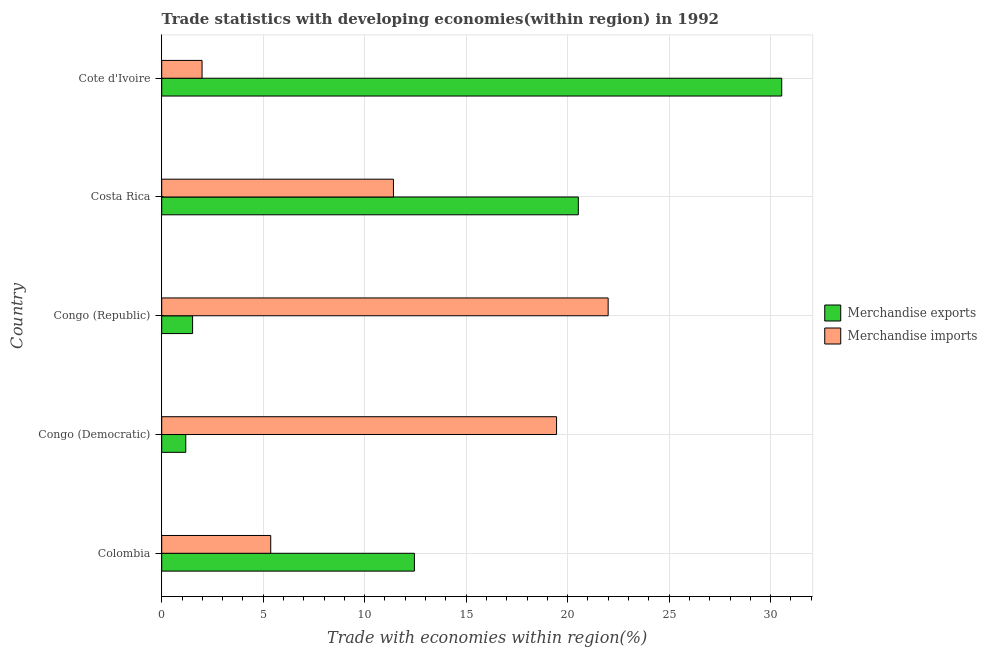How many different coloured bars are there?
Give a very brief answer. 2. Are the number of bars per tick equal to the number of legend labels?
Ensure brevity in your answer.  Yes. How many bars are there on the 1st tick from the bottom?
Make the answer very short. 2. What is the label of the 3rd group of bars from the top?
Give a very brief answer. Congo (Republic). In how many cases, is the number of bars for a given country not equal to the number of legend labels?
Provide a short and direct response. 0. What is the merchandise imports in Colombia?
Make the answer very short. 5.37. Across all countries, what is the maximum merchandise exports?
Keep it short and to the point. 30.55. Across all countries, what is the minimum merchandise exports?
Provide a short and direct response. 1.19. In which country was the merchandise imports maximum?
Offer a terse response. Congo (Republic). In which country was the merchandise imports minimum?
Keep it short and to the point. Cote d'Ivoire. What is the total merchandise imports in the graph?
Your answer should be compact. 60.22. What is the difference between the merchandise exports in Congo (Democratic) and that in Congo (Republic)?
Your answer should be compact. -0.34. What is the difference between the merchandise exports in Costa Rica and the merchandise imports in Congo (Republic)?
Make the answer very short. -1.47. What is the average merchandise imports per country?
Offer a very short reply. 12.04. What is the difference between the merchandise exports and merchandise imports in Colombia?
Make the answer very short. 7.08. What is the ratio of the merchandise exports in Congo (Democratic) to that in Costa Rica?
Your answer should be very brief. 0.06. What is the difference between the highest and the second highest merchandise exports?
Offer a very short reply. 10.02. What is the difference between the highest and the lowest merchandise exports?
Give a very brief answer. 29.36. In how many countries, is the merchandise imports greater than the average merchandise imports taken over all countries?
Keep it short and to the point. 2. What does the 2nd bar from the top in Colombia represents?
Ensure brevity in your answer.  Merchandise exports. Are all the bars in the graph horizontal?
Give a very brief answer. Yes. How many countries are there in the graph?
Offer a very short reply. 5. What is the difference between two consecutive major ticks on the X-axis?
Make the answer very short. 5. Where does the legend appear in the graph?
Keep it short and to the point. Center right. What is the title of the graph?
Provide a short and direct response. Trade statistics with developing economies(within region) in 1992. What is the label or title of the X-axis?
Your answer should be compact. Trade with economies within region(%). What is the Trade with economies within region(%) of Merchandise exports in Colombia?
Give a very brief answer. 12.45. What is the Trade with economies within region(%) in Merchandise imports in Colombia?
Keep it short and to the point. 5.37. What is the Trade with economies within region(%) of Merchandise exports in Congo (Democratic)?
Make the answer very short. 1.19. What is the Trade with economies within region(%) in Merchandise imports in Congo (Democratic)?
Keep it short and to the point. 19.45. What is the Trade with economies within region(%) in Merchandise exports in Congo (Republic)?
Keep it short and to the point. 1.52. What is the Trade with economies within region(%) of Merchandise imports in Congo (Republic)?
Make the answer very short. 22. What is the Trade with economies within region(%) in Merchandise exports in Costa Rica?
Give a very brief answer. 20.53. What is the Trade with economies within region(%) of Merchandise imports in Costa Rica?
Make the answer very short. 11.42. What is the Trade with economies within region(%) of Merchandise exports in Cote d'Ivoire?
Provide a succinct answer. 30.55. What is the Trade with economies within region(%) in Merchandise imports in Cote d'Ivoire?
Make the answer very short. 1.99. Across all countries, what is the maximum Trade with economies within region(%) in Merchandise exports?
Provide a short and direct response. 30.55. Across all countries, what is the maximum Trade with economies within region(%) of Merchandise imports?
Your answer should be compact. 22. Across all countries, what is the minimum Trade with economies within region(%) of Merchandise exports?
Your answer should be very brief. 1.19. Across all countries, what is the minimum Trade with economies within region(%) in Merchandise imports?
Ensure brevity in your answer.  1.99. What is the total Trade with economies within region(%) in Merchandise exports in the graph?
Ensure brevity in your answer.  66.23. What is the total Trade with economies within region(%) of Merchandise imports in the graph?
Offer a very short reply. 60.22. What is the difference between the Trade with economies within region(%) in Merchandise exports in Colombia and that in Congo (Democratic)?
Provide a succinct answer. 11.26. What is the difference between the Trade with economies within region(%) in Merchandise imports in Colombia and that in Congo (Democratic)?
Your answer should be compact. -14.08. What is the difference between the Trade with economies within region(%) of Merchandise exports in Colombia and that in Congo (Republic)?
Provide a succinct answer. 10.93. What is the difference between the Trade with economies within region(%) in Merchandise imports in Colombia and that in Congo (Republic)?
Ensure brevity in your answer.  -16.62. What is the difference between the Trade with economies within region(%) in Merchandise exports in Colombia and that in Costa Rica?
Provide a short and direct response. -8.08. What is the difference between the Trade with economies within region(%) of Merchandise imports in Colombia and that in Costa Rica?
Ensure brevity in your answer.  -6.05. What is the difference between the Trade with economies within region(%) of Merchandise exports in Colombia and that in Cote d'Ivoire?
Your answer should be very brief. -18.1. What is the difference between the Trade with economies within region(%) of Merchandise imports in Colombia and that in Cote d'Ivoire?
Provide a succinct answer. 3.38. What is the difference between the Trade with economies within region(%) of Merchandise exports in Congo (Democratic) and that in Congo (Republic)?
Offer a very short reply. -0.34. What is the difference between the Trade with economies within region(%) in Merchandise imports in Congo (Democratic) and that in Congo (Republic)?
Provide a short and direct response. -2.54. What is the difference between the Trade with economies within region(%) in Merchandise exports in Congo (Democratic) and that in Costa Rica?
Give a very brief answer. -19.34. What is the difference between the Trade with economies within region(%) in Merchandise imports in Congo (Democratic) and that in Costa Rica?
Give a very brief answer. 8.04. What is the difference between the Trade with economies within region(%) of Merchandise exports in Congo (Democratic) and that in Cote d'Ivoire?
Provide a succinct answer. -29.36. What is the difference between the Trade with economies within region(%) in Merchandise imports in Congo (Democratic) and that in Cote d'Ivoire?
Keep it short and to the point. 17.46. What is the difference between the Trade with economies within region(%) in Merchandise exports in Congo (Republic) and that in Costa Rica?
Give a very brief answer. -19. What is the difference between the Trade with economies within region(%) of Merchandise imports in Congo (Republic) and that in Costa Rica?
Your answer should be compact. 10.58. What is the difference between the Trade with economies within region(%) of Merchandise exports in Congo (Republic) and that in Cote d'Ivoire?
Give a very brief answer. -29.02. What is the difference between the Trade with economies within region(%) of Merchandise imports in Congo (Republic) and that in Cote d'Ivoire?
Give a very brief answer. 20.01. What is the difference between the Trade with economies within region(%) in Merchandise exports in Costa Rica and that in Cote d'Ivoire?
Keep it short and to the point. -10.02. What is the difference between the Trade with economies within region(%) of Merchandise imports in Costa Rica and that in Cote d'Ivoire?
Your answer should be compact. 9.43. What is the difference between the Trade with economies within region(%) in Merchandise exports in Colombia and the Trade with economies within region(%) in Merchandise imports in Congo (Democratic)?
Give a very brief answer. -7. What is the difference between the Trade with economies within region(%) in Merchandise exports in Colombia and the Trade with economies within region(%) in Merchandise imports in Congo (Republic)?
Keep it short and to the point. -9.55. What is the difference between the Trade with economies within region(%) in Merchandise exports in Colombia and the Trade with economies within region(%) in Merchandise imports in Costa Rica?
Ensure brevity in your answer.  1.03. What is the difference between the Trade with economies within region(%) of Merchandise exports in Colombia and the Trade with economies within region(%) of Merchandise imports in Cote d'Ivoire?
Provide a succinct answer. 10.46. What is the difference between the Trade with economies within region(%) of Merchandise exports in Congo (Democratic) and the Trade with economies within region(%) of Merchandise imports in Congo (Republic)?
Provide a short and direct response. -20.81. What is the difference between the Trade with economies within region(%) of Merchandise exports in Congo (Democratic) and the Trade with economies within region(%) of Merchandise imports in Costa Rica?
Your response must be concise. -10.23. What is the difference between the Trade with economies within region(%) of Merchandise exports in Congo (Democratic) and the Trade with economies within region(%) of Merchandise imports in Cote d'Ivoire?
Your answer should be compact. -0.8. What is the difference between the Trade with economies within region(%) in Merchandise exports in Congo (Republic) and the Trade with economies within region(%) in Merchandise imports in Costa Rica?
Offer a terse response. -9.9. What is the difference between the Trade with economies within region(%) in Merchandise exports in Congo (Republic) and the Trade with economies within region(%) in Merchandise imports in Cote d'Ivoire?
Offer a very short reply. -0.47. What is the difference between the Trade with economies within region(%) of Merchandise exports in Costa Rica and the Trade with economies within region(%) of Merchandise imports in Cote d'Ivoire?
Ensure brevity in your answer.  18.54. What is the average Trade with economies within region(%) in Merchandise exports per country?
Keep it short and to the point. 13.25. What is the average Trade with economies within region(%) in Merchandise imports per country?
Provide a short and direct response. 12.04. What is the difference between the Trade with economies within region(%) of Merchandise exports and Trade with economies within region(%) of Merchandise imports in Colombia?
Keep it short and to the point. 7.08. What is the difference between the Trade with economies within region(%) of Merchandise exports and Trade with economies within region(%) of Merchandise imports in Congo (Democratic)?
Offer a very short reply. -18.27. What is the difference between the Trade with economies within region(%) in Merchandise exports and Trade with economies within region(%) in Merchandise imports in Congo (Republic)?
Give a very brief answer. -20.47. What is the difference between the Trade with economies within region(%) of Merchandise exports and Trade with economies within region(%) of Merchandise imports in Costa Rica?
Give a very brief answer. 9.11. What is the difference between the Trade with economies within region(%) of Merchandise exports and Trade with economies within region(%) of Merchandise imports in Cote d'Ivoire?
Offer a very short reply. 28.56. What is the ratio of the Trade with economies within region(%) in Merchandise exports in Colombia to that in Congo (Democratic)?
Offer a terse response. 10.51. What is the ratio of the Trade with economies within region(%) of Merchandise imports in Colombia to that in Congo (Democratic)?
Provide a succinct answer. 0.28. What is the ratio of the Trade with economies within region(%) of Merchandise exports in Colombia to that in Congo (Republic)?
Make the answer very short. 8.18. What is the ratio of the Trade with economies within region(%) of Merchandise imports in Colombia to that in Congo (Republic)?
Give a very brief answer. 0.24. What is the ratio of the Trade with economies within region(%) in Merchandise exports in Colombia to that in Costa Rica?
Your response must be concise. 0.61. What is the ratio of the Trade with economies within region(%) of Merchandise imports in Colombia to that in Costa Rica?
Your response must be concise. 0.47. What is the ratio of the Trade with economies within region(%) of Merchandise exports in Colombia to that in Cote d'Ivoire?
Make the answer very short. 0.41. What is the ratio of the Trade with economies within region(%) in Merchandise imports in Colombia to that in Cote d'Ivoire?
Offer a terse response. 2.7. What is the ratio of the Trade with economies within region(%) of Merchandise exports in Congo (Democratic) to that in Congo (Republic)?
Provide a succinct answer. 0.78. What is the ratio of the Trade with economies within region(%) of Merchandise imports in Congo (Democratic) to that in Congo (Republic)?
Offer a terse response. 0.88. What is the ratio of the Trade with economies within region(%) of Merchandise exports in Congo (Democratic) to that in Costa Rica?
Your response must be concise. 0.06. What is the ratio of the Trade with economies within region(%) of Merchandise imports in Congo (Democratic) to that in Costa Rica?
Provide a short and direct response. 1.7. What is the ratio of the Trade with economies within region(%) of Merchandise exports in Congo (Democratic) to that in Cote d'Ivoire?
Offer a very short reply. 0.04. What is the ratio of the Trade with economies within region(%) of Merchandise imports in Congo (Democratic) to that in Cote d'Ivoire?
Provide a short and direct response. 9.78. What is the ratio of the Trade with economies within region(%) of Merchandise exports in Congo (Republic) to that in Costa Rica?
Keep it short and to the point. 0.07. What is the ratio of the Trade with economies within region(%) of Merchandise imports in Congo (Republic) to that in Costa Rica?
Keep it short and to the point. 1.93. What is the ratio of the Trade with economies within region(%) in Merchandise exports in Congo (Republic) to that in Cote d'Ivoire?
Ensure brevity in your answer.  0.05. What is the ratio of the Trade with economies within region(%) in Merchandise imports in Congo (Republic) to that in Cote d'Ivoire?
Make the answer very short. 11.06. What is the ratio of the Trade with economies within region(%) of Merchandise exports in Costa Rica to that in Cote d'Ivoire?
Give a very brief answer. 0.67. What is the ratio of the Trade with economies within region(%) in Merchandise imports in Costa Rica to that in Cote d'Ivoire?
Provide a succinct answer. 5.74. What is the difference between the highest and the second highest Trade with economies within region(%) in Merchandise exports?
Your answer should be compact. 10.02. What is the difference between the highest and the second highest Trade with economies within region(%) in Merchandise imports?
Make the answer very short. 2.54. What is the difference between the highest and the lowest Trade with economies within region(%) in Merchandise exports?
Provide a succinct answer. 29.36. What is the difference between the highest and the lowest Trade with economies within region(%) in Merchandise imports?
Your answer should be compact. 20.01. 